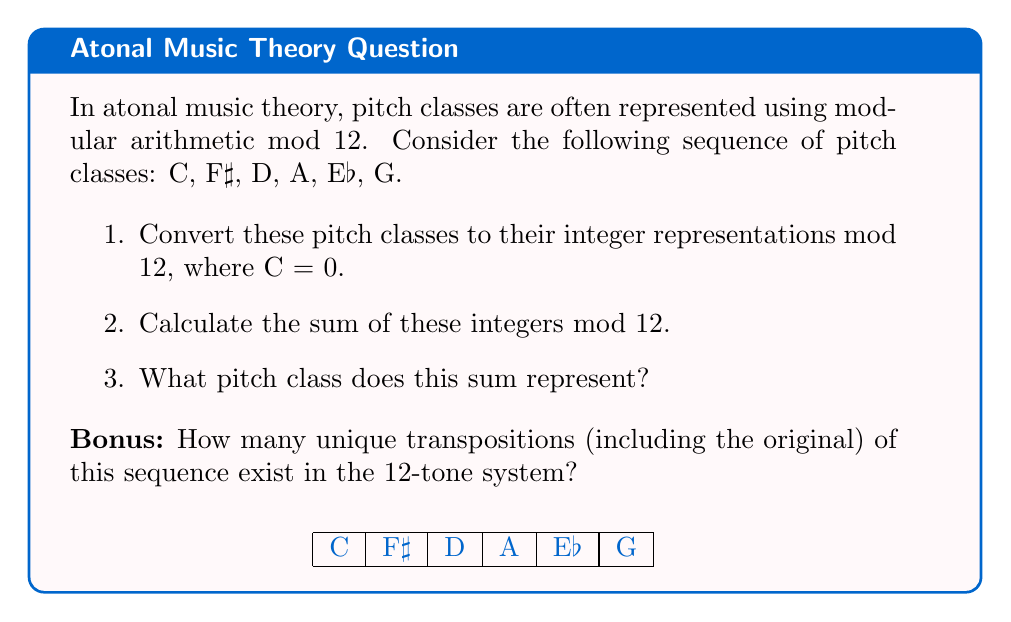Help me with this question. Let's approach this step-by-step:

1. Converting pitch classes to integers mod 12:
   C = 0
   F♯ = 6
   D = 2
   A = 9
   E♭ = 3
   G = 7

2. Calculating the sum mod 12:
   $$(0 + 6 + 2 + 9 + 3 + 7) \bmod 12$$
   $$= 27 \bmod 12$$
   $$= 3$$

3. The pitch class represented by 3 is E♭.

Bonus:
In the 12-tone system, there are always 12 unique transpositions of any sequence, including the original. This is because:

- Each transposition shifts all pitch classes by the same interval.
- There are 12 possible intervals to shift by (0 to 11 semitones).
- After shifting by 12 semitones, we return to the original sequence due to the modular nature of the system.

Mathematically, this can be represented as the group of transpositions being isomorphic to the cyclic group $\mathbb{Z}_{12}$ under addition modulo 12.
Answer: E♭; 12 transpositions 